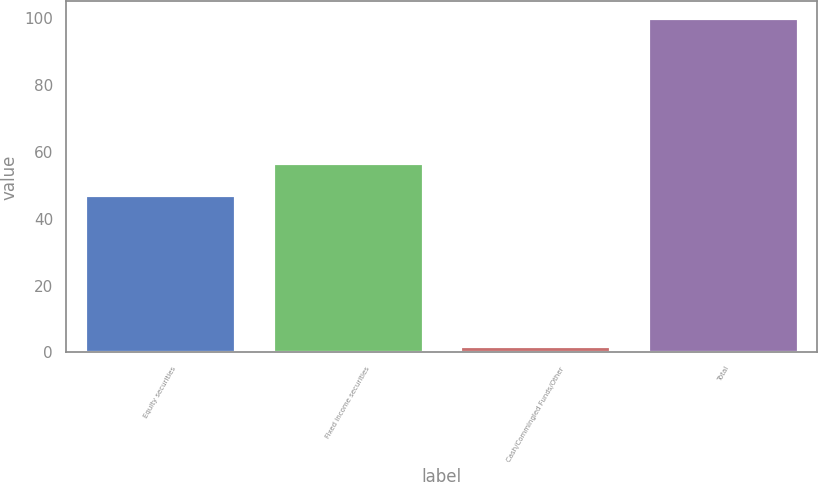Convert chart to OTSL. <chart><loc_0><loc_0><loc_500><loc_500><bar_chart><fcel>Equity securities<fcel>Fixed income securities<fcel>Cash/Commingled Funds/Other<fcel>Total<nl><fcel>47<fcel>56.8<fcel>2<fcel>100<nl></chart> 